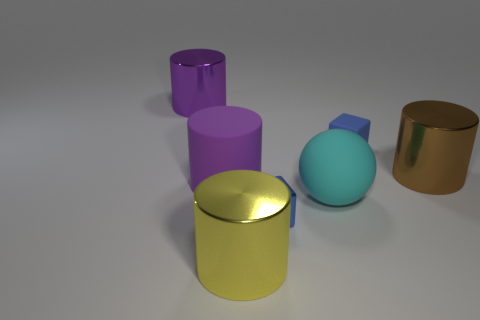Subtract 1 cylinders. How many cylinders are left? 3 Add 1 matte blocks. How many objects exist? 8 Subtract all balls. How many objects are left? 6 Subtract all large purple metal things. Subtract all big green cylinders. How many objects are left? 6 Add 6 large purple shiny cylinders. How many large purple shiny cylinders are left? 7 Add 5 large purple metal things. How many large purple metal things exist? 6 Subtract 1 purple cylinders. How many objects are left? 6 